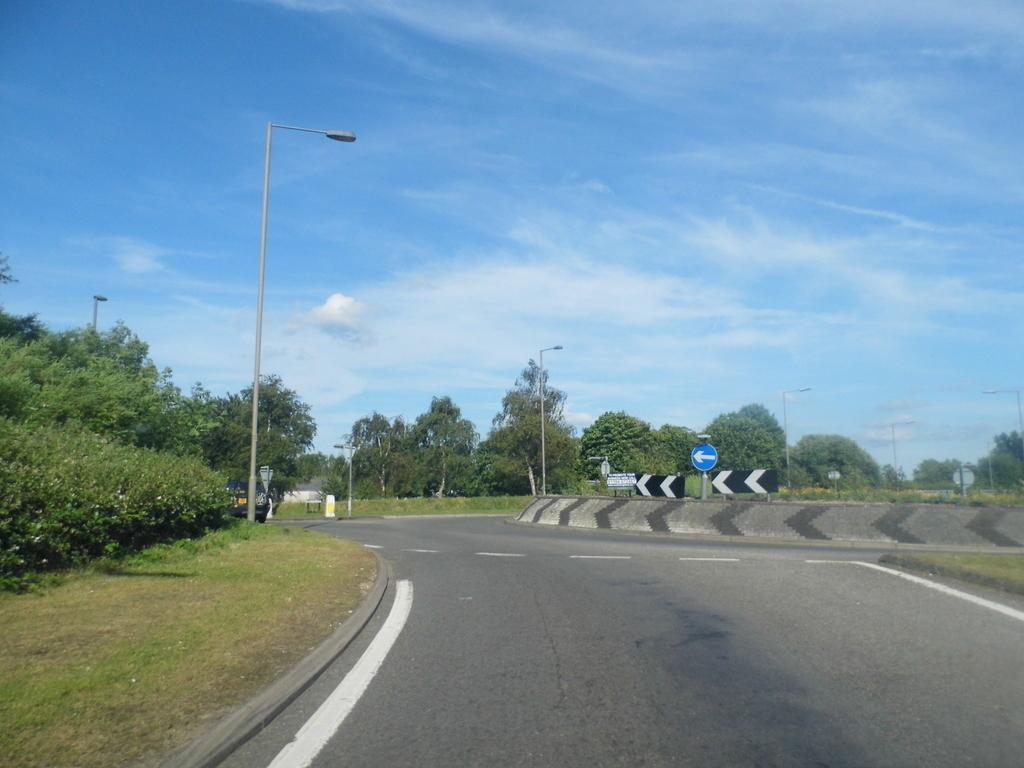Please provide a concise description of this image. In this picture I can see street lights, trees, a road which has white lines on it and grass. Here I can see some sign boards and the sky in the background. 